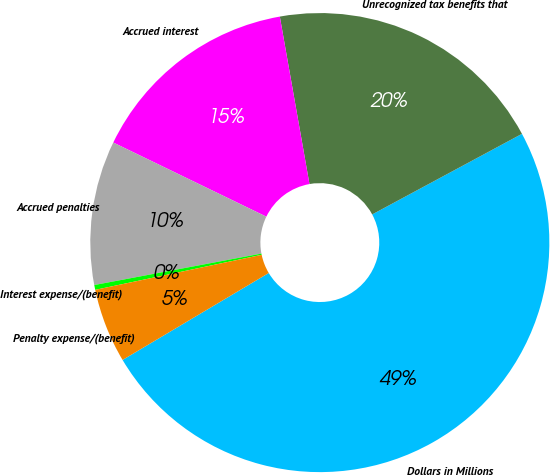Convert chart to OTSL. <chart><loc_0><loc_0><loc_500><loc_500><pie_chart><fcel>Dollars in Millions<fcel>Unrecognized tax benefits that<fcel>Accrued interest<fcel>Accrued penalties<fcel>Interest expense/(benefit)<fcel>Penalty expense/(benefit)<nl><fcel>49.31%<fcel>19.93%<fcel>15.03%<fcel>10.14%<fcel>0.34%<fcel>5.24%<nl></chart> 